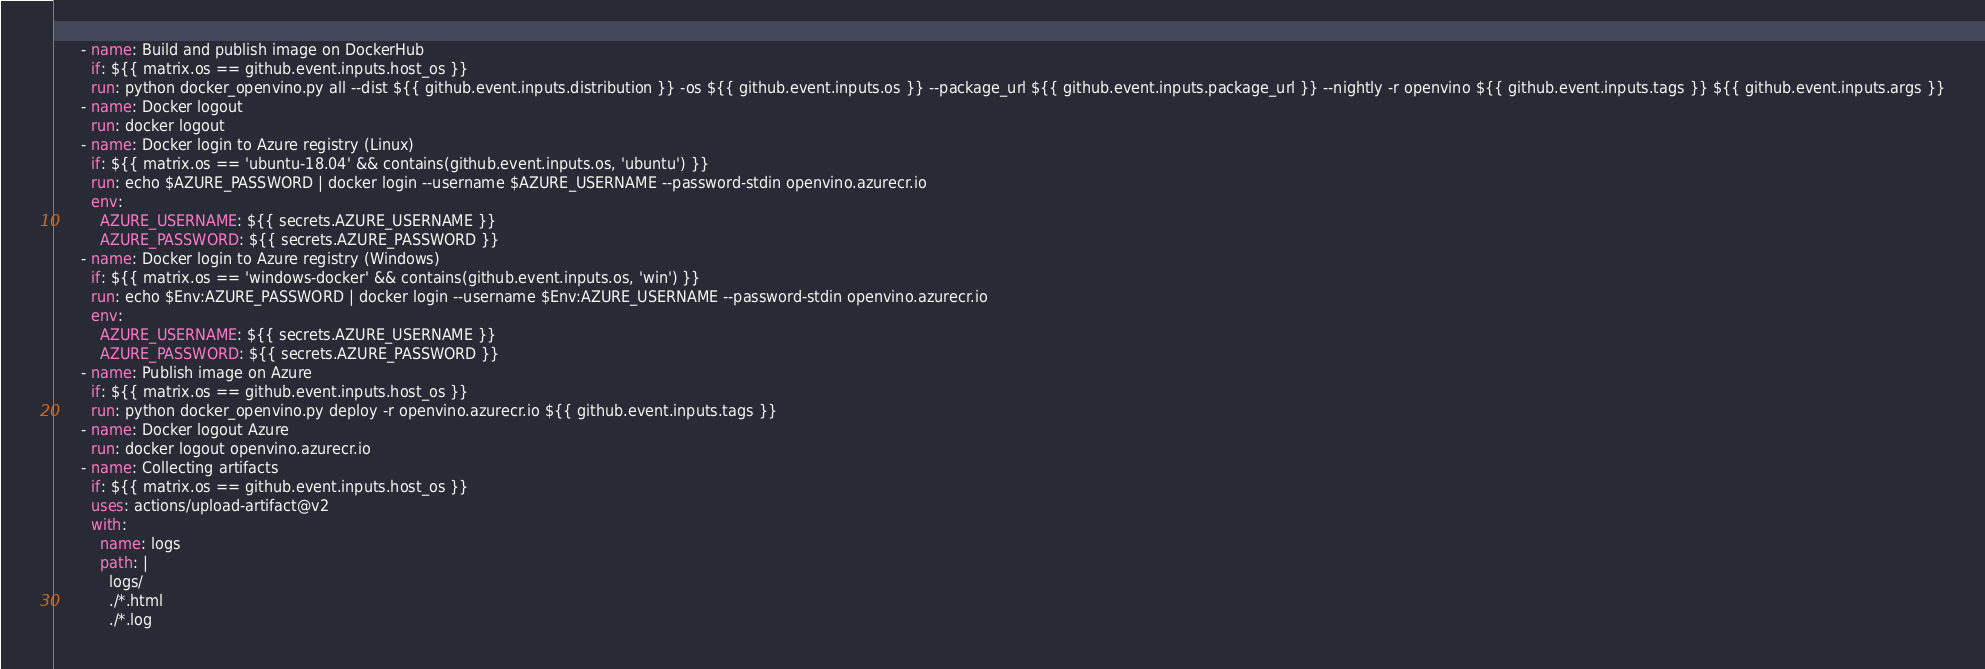<code> <loc_0><loc_0><loc_500><loc_500><_YAML_>      - name: Build and publish image on DockerHub
        if: ${{ matrix.os == github.event.inputs.host_os }}
        run: python docker_openvino.py all --dist ${{ github.event.inputs.distribution }} -os ${{ github.event.inputs.os }} --package_url ${{ github.event.inputs.package_url }} --nightly -r openvino ${{ github.event.inputs.tags }} ${{ github.event.inputs.args }}
      - name: Docker logout
        run: docker logout
      - name: Docker login to Azure registry (Linux)
        if: ${{ matrix.os == 'ubuntu-18.04' && contains(github.event.inputs.os, 'ubuntu') }}
        run: echo $AZURE_PASSWORD | docker login --username $AZURE_USERNAME --password-stdin openvino.azurecr.io
        env:
          AZURE_USERNAME: ${{ secrets.AZURE_USERNAME }}
          AZURE_PASSWORD: ${{ secrets.AZURE_PASSWORD }}
      - name: Docker login to Azure registry (Windows)
        if: ${{ matrix.os == 'windows-docker' && contains(github.event.inputs.os, 'win') }}
        run: echo $Env:AZURE_PASSWORD | docker login --username $Env:AZURE_USERNAME --password-stdin openvino.azurecr.io
        env:
          AZURE_USERNAME: ${{ secrets.AZURE_USERNAME }}
          AZURE_PASSWORD: ${{ secrets.AZURE_PASSWORD }}
      - name: Publish image on Azure
        if: ${{ matrix.os == github.event.inputs.host_os }}
        run: python docker_openvino.py deploy -r openvino.azurecr.io ${{ github.event.inputs.tags }}
      - name: Docker logout Azure
        run: docker logout openvino.azurecr.io
      - name: Collecting artifacts
        if: ${{ matrix.os == github.event.inputs.host_os }}
        uses: actions/upload-artifact@v2
        with:
          name: logs
          path: |
            logs/
            ./*.html
            ./*.log
</code> 